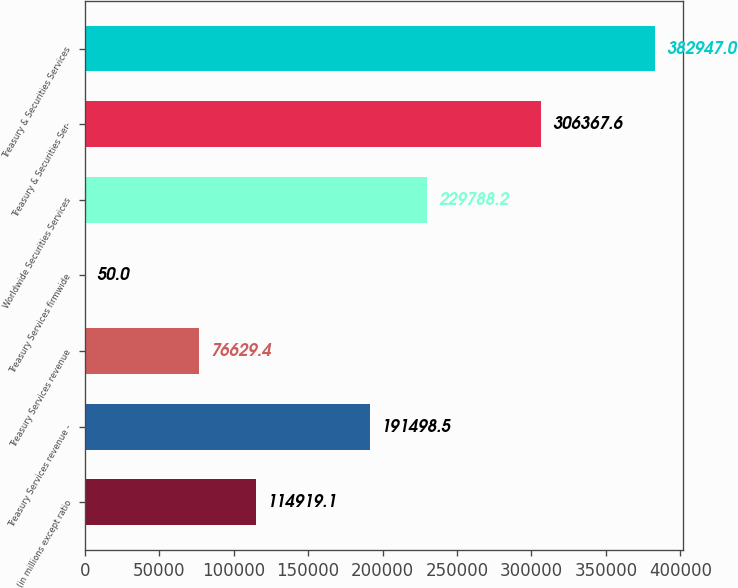<chart> <loc_0><loc_0><loc_500><loc_500><bar_chart><fcel>(in millions except ratio<fcel>Treasury Services revenue -<fcel>Treasury Services revenue<fcel>Treasury Services firmwide<fcel>Worldwide Securities Services<fcel>Treasury & Securities Ser-<fcel>Treasury & Securities Services<nl><fcel>114919<fcel>191498<fcel>76629.4<fcel>50<fcel>229788<fcel>306368<fcel>382947<nl></chart> 